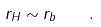<formula> <loc_0><loc_0><loc_500><loc_500>r _ { H } \sim r _ { b } \quad .</formula> 